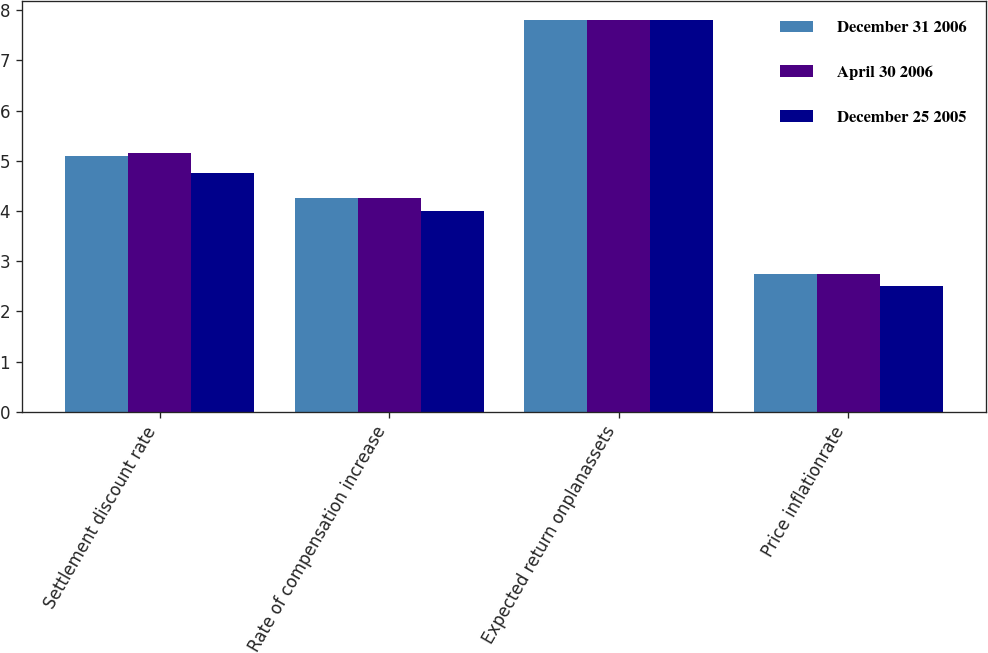Convert chart to OTSL. <chart><loc_0><loc_0><loc_500><loc_500><stacked_bar_chart><ecel><fcel>Settlement discount rate<fcel>Rate of compensation increase<fcel>Expected return onplanassets<fcel>Price inflationrate<nl><fcel>December 31 2006<fcel>5.1<fcel>4.25<fcel>7.8<fcel>2.75<nl><fcel>April 30 2006<fcel>5.15<fcel>4.25<fcel>7.8<fcel>2.75<nl><fcel>December 25 2005<fcel>4.75<fcel>4<fcel>7.8<fcel>2.5<nl></chart> 